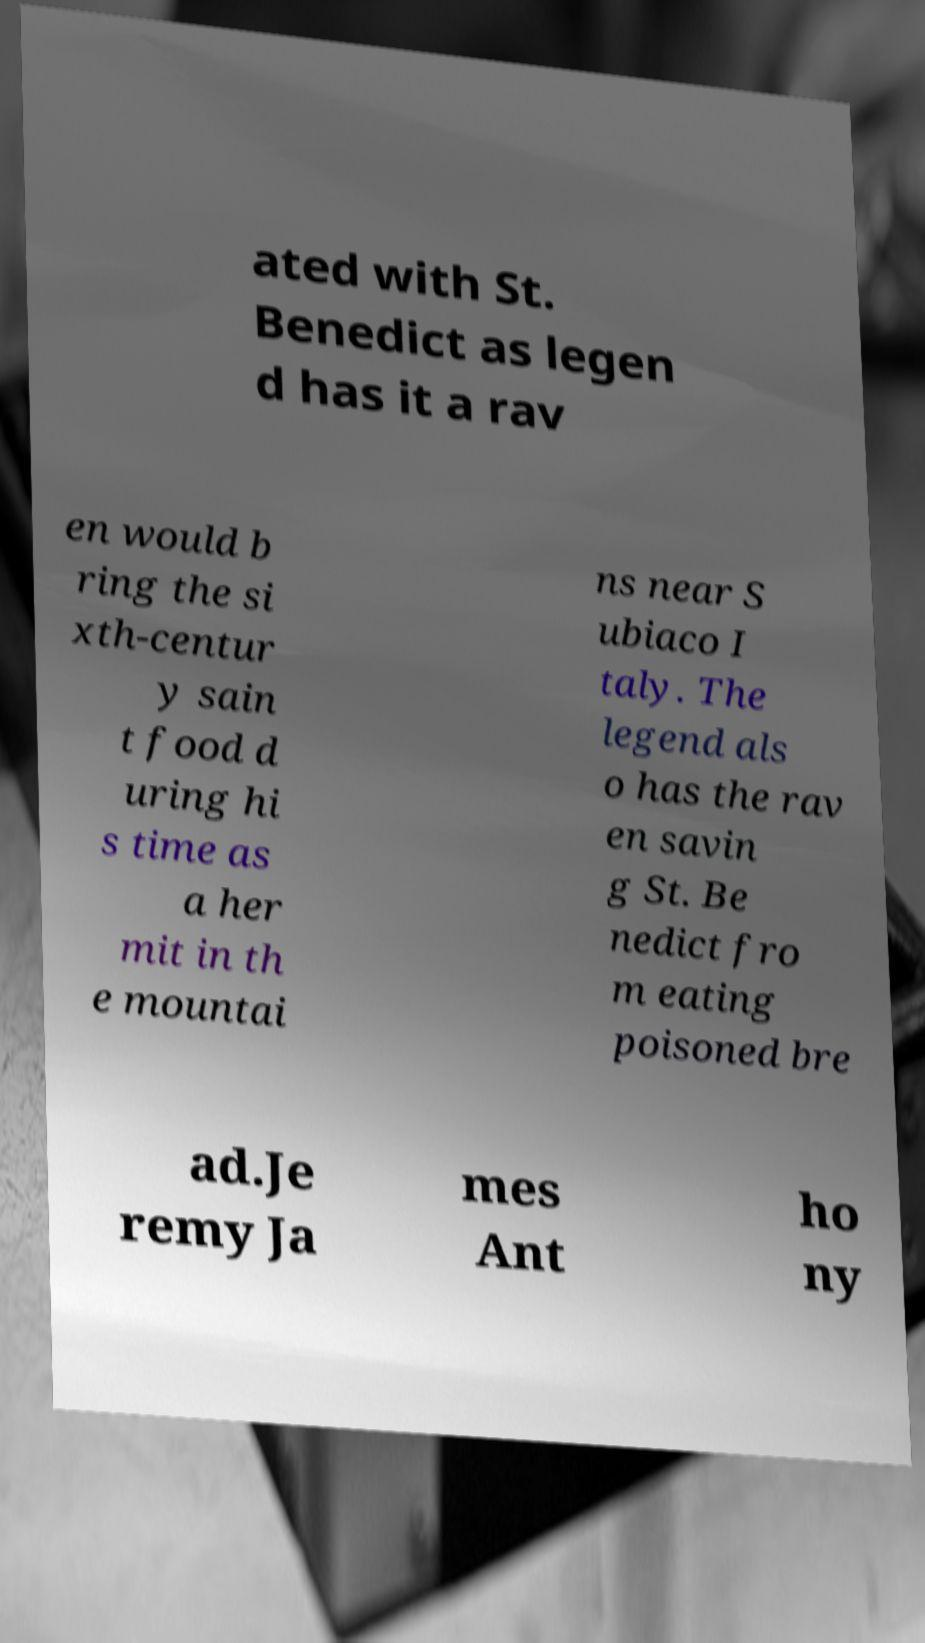I need the written content from this picture converted into text. Can you do that? ated with St. Benedict as legen d has it a rav en would b ring the si xth-centur y sain t food d uring hi s time as a her mit in th e mountai ns near S ubiaco I taly. The legend als o has the rav en savin g St. Be nedict fro m eating poisoned bre ad.Je remy Ja mes Ant ho ny 